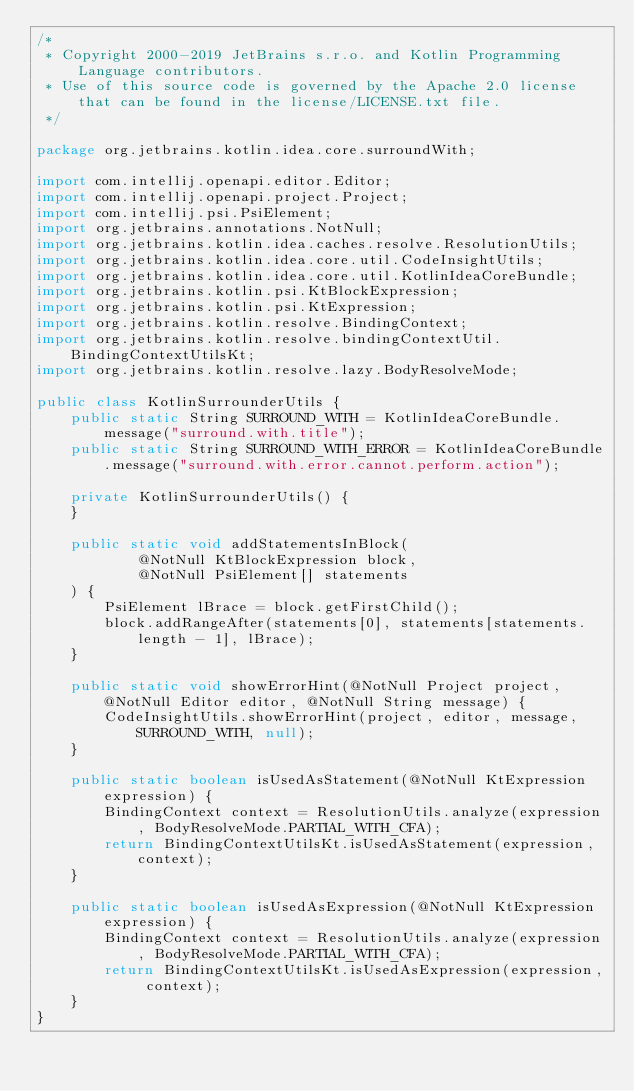<code> <loc_0><loc_0><loc_500><loc_500><_Java_>/*
 * Copyright 2000-2019 JetBrains s.r.o. and Kotlin Programming Language contributors.
 * Use of this source code is governed by the Apache 2.0 license that can be found in the license/LICENSE.txt file.
 */

package org.jetbrains.kotlin.idea.core.surroundWith;

import com.intellij.openapi.editor.Editor;
import com.intellij.openapi.project.Project;
import com.intellij.psi.PsiElement;
import org.jetbrains.annotations.NotNull;
import org.jetbrains.kotlin.idea.caches.resolve.ResolutionUtils;
import org.jetbrains.kotlin.idea.core.util.CodeInsightUtils;
import org.jetbrains.kotlin.idea.core.util.KotlinIdeaCoreBundle;
import org.jetbrains.kotlin.psi.KtBlockExpression;
import org.jetbrains.kotlin.psi.KtExpression;
import org.jetbrains.kotlin.resolve.BindingContext;
import org.jetbrains.kotlin.resolve.bindingContextUtil.BindingContextUtilsKt;
import org.jetbrains.kotlin.resolve.lazy.BodyResolveMode;

public class KotlinSurrounderUtils {
    public static String SURROUND_WITH = KotlinIdeaCoreBundle.message("surround.with.title");
    public static String SURROUND_WITH_ERROR = KotlinIdeaCoreBundle.message("surround.with.error.cannot.perform.action");

    private KotlinSurrounderUtils() {
    }

    public static void addStatementsInBlock(
            @NotNull KtBlockExpression block,
            @NotNull PsiElement[] statements
    ) {
        PsiElement lBrace = block.getFirstChild();
        block.addRangeAfter(statements[0], statements[statements.length - 1], lBrace);
    }

    public static void showErrorHint(@NotNull Project project, @NotNull Editor editor, @NotNull String message) {
        CodeInsightUtils.showErrorHint(project, editor, message, SURROUND_WITH, null);
    }

    public static boolean isUsedAsStatement(@NotNull KtExpression expression) {
        BindingContext context = ResolutionUtils.analyze(expression, BodyResolveMode.PARTIAL_WITH_CFA);
        return BindingContextUtilsKt.isUsedAsStatement(expression, context);
    }

    public static boolean isUsedAsExpression(@NotNull KtExpression expression) {
        BindingContext context = ResolutionUtils.analyze(expression, BodyResolveMode.PARTIAL_WITH_CFA);
        return BindingContextUtilsKt.isUsedAsExpression(expression, context);
    }
}
</code> 